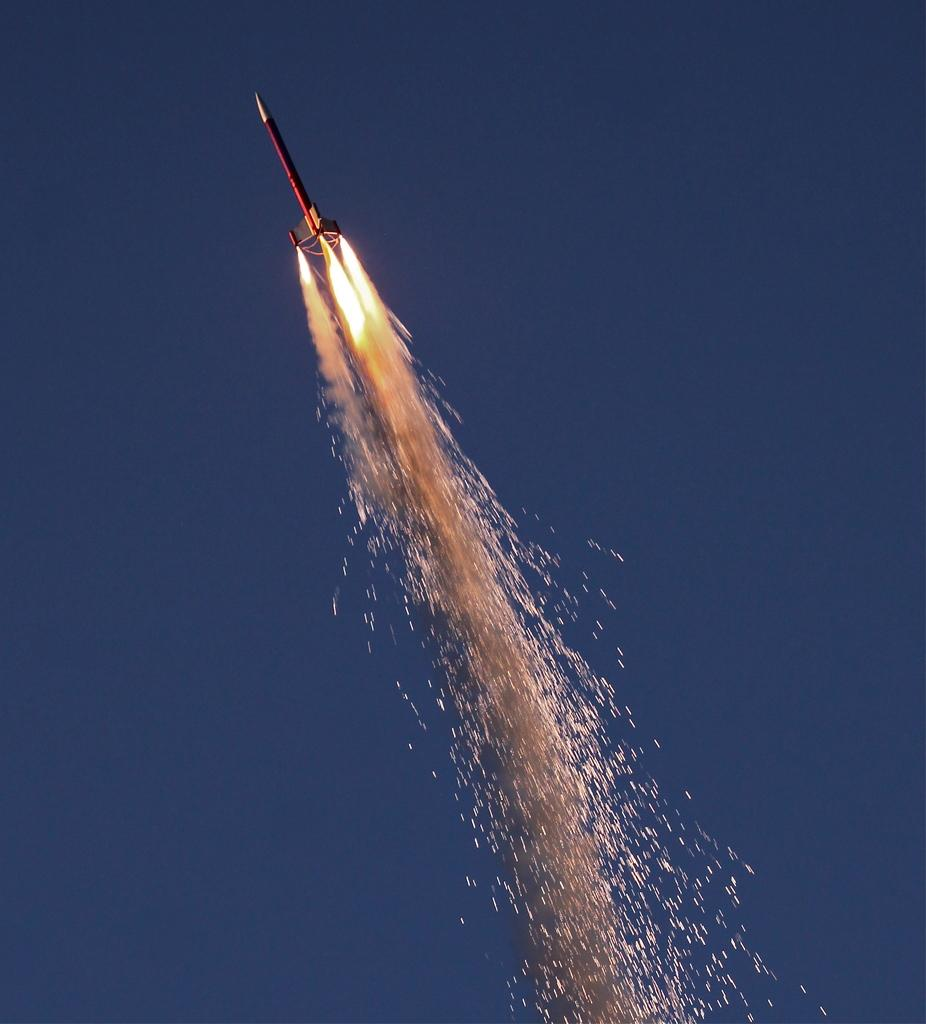What is the main subject of the image? The main subject of the image is a rocket. What can be observed about the rocket in the image? The rocket has fire and is flying in the sky. What type of cloud can be seen in the image? There is no cloud present in the image; it features a rocket flying in the sky with fire. Can you tell me how many baseballs are visible in the image? There are no baseballs present in the image. 